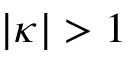<formula> <loc_0><loc_0><loc_500><loc_500>| \kappa | > 1</formula> 